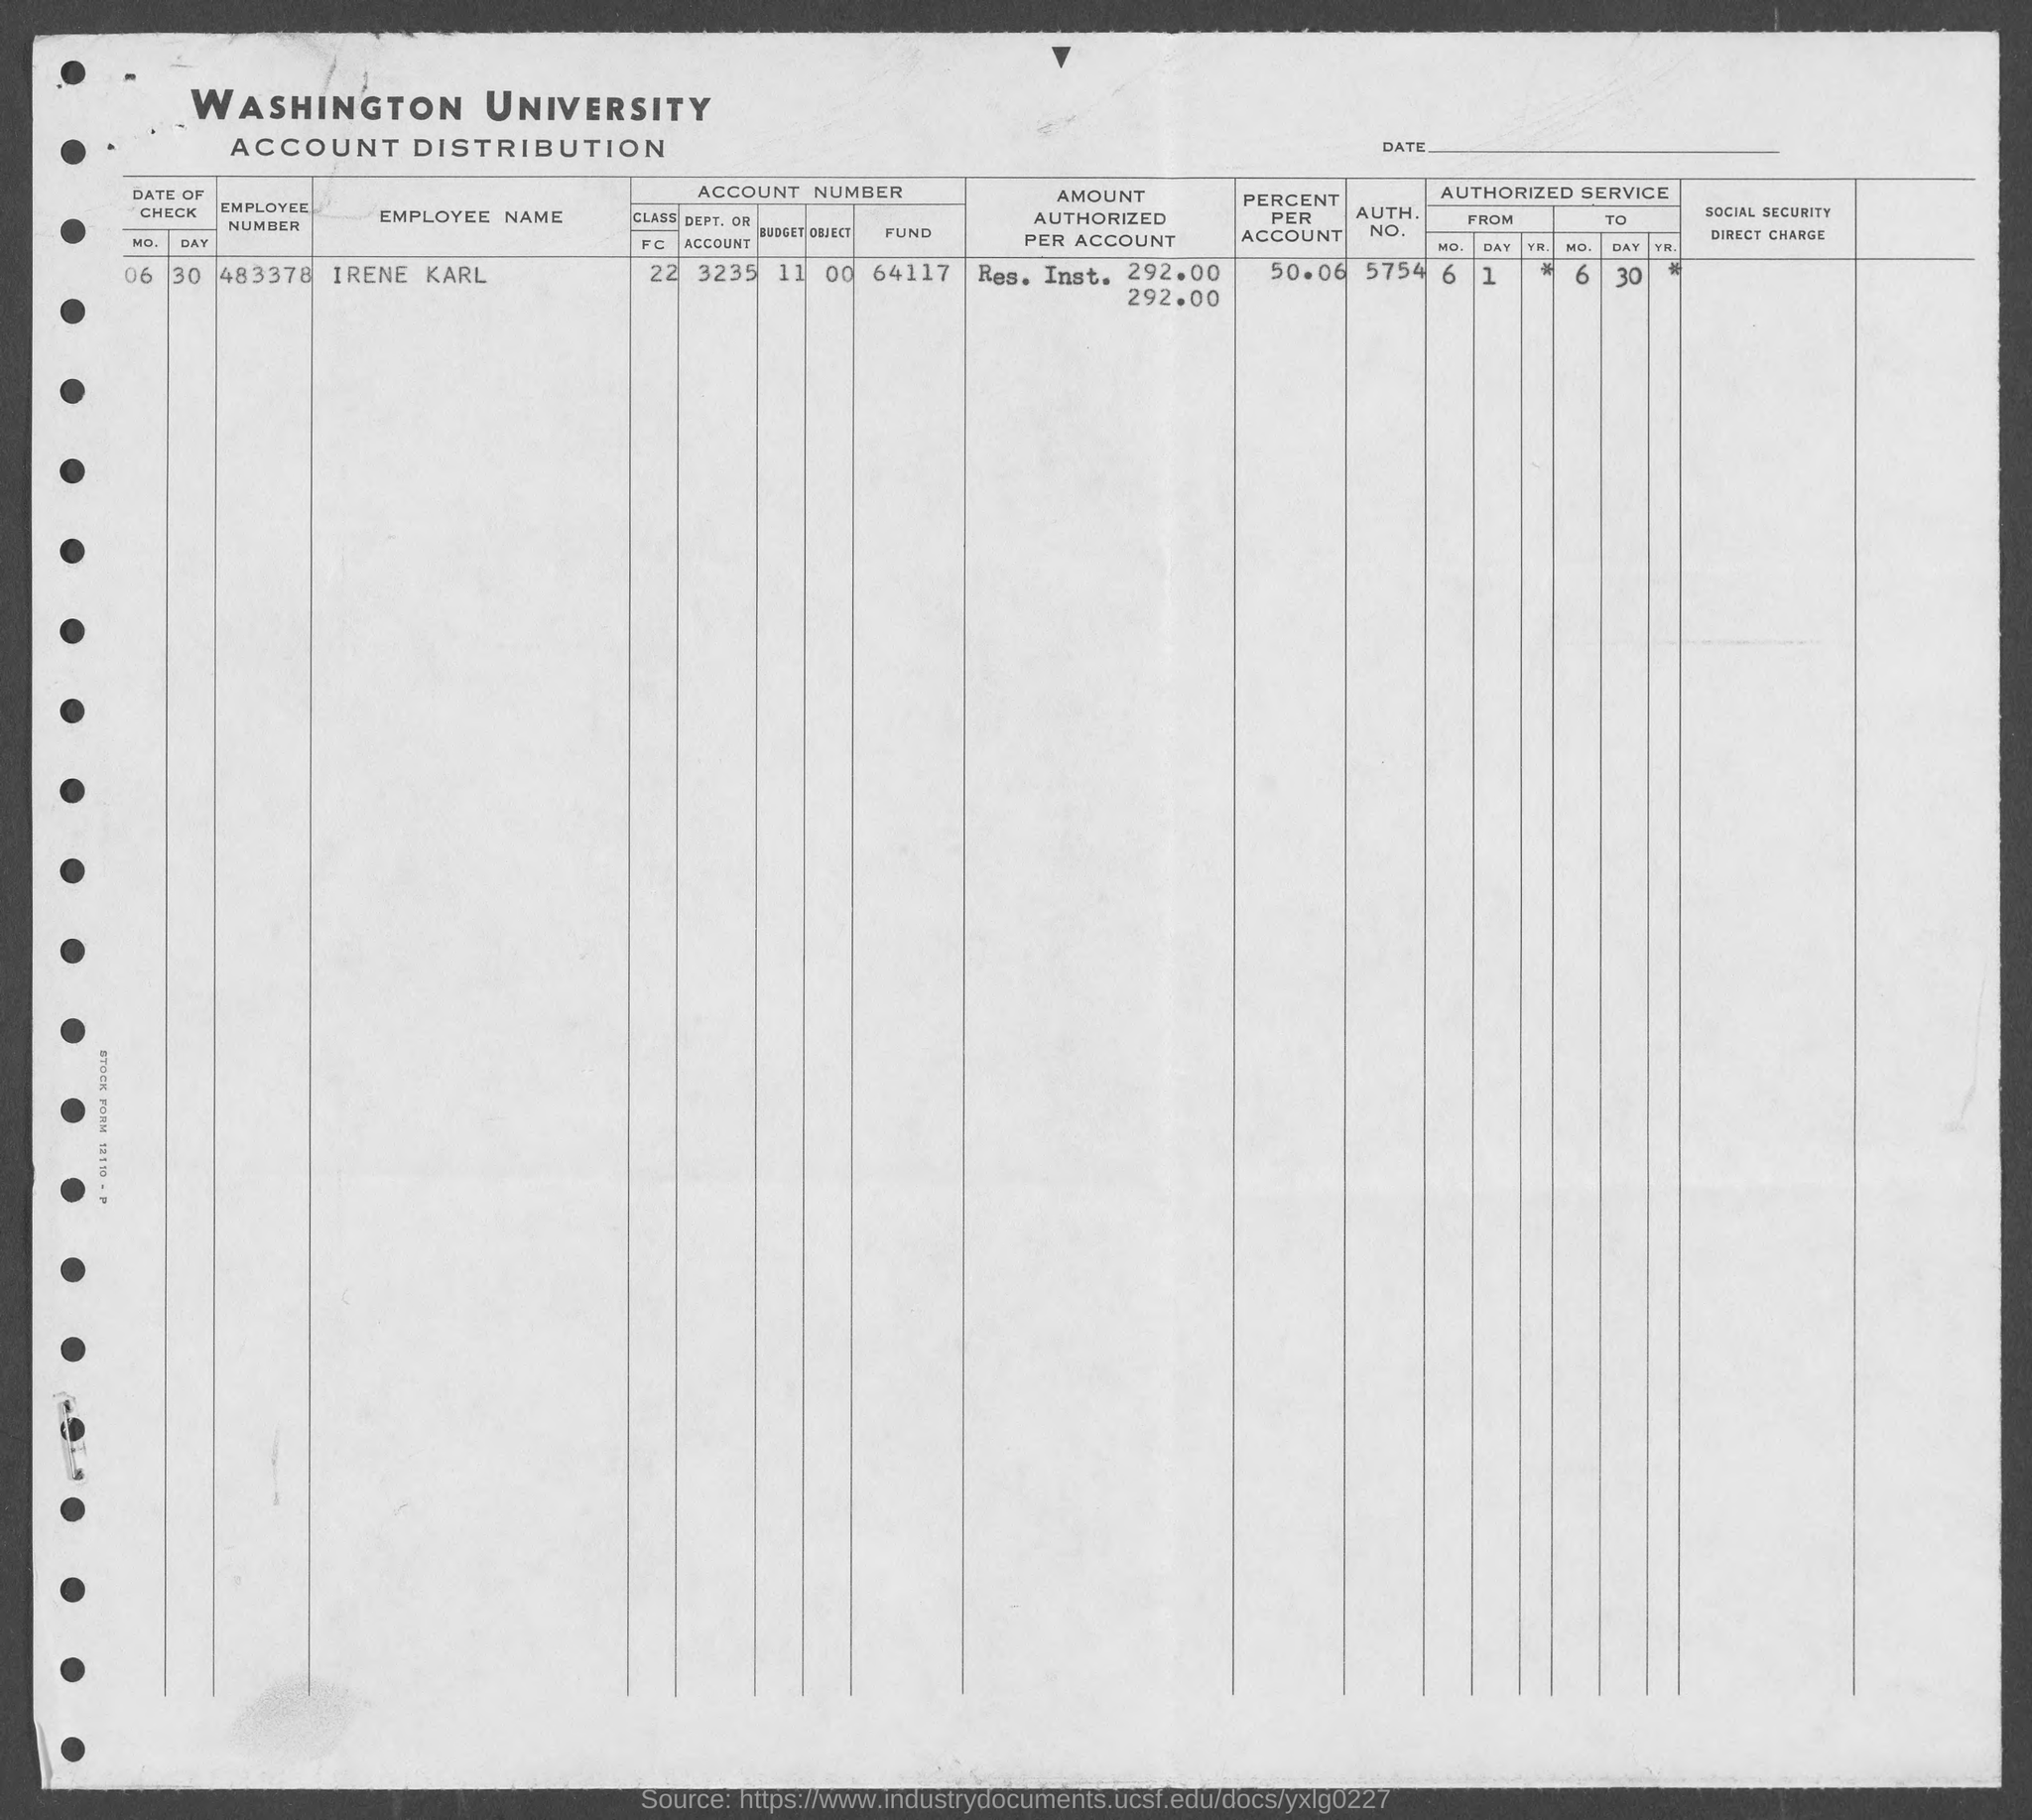What is the auth. no. mentioned in the given form ?
Make the answer very short. 5754. What is the value of percent per account as mentioned in the given form ?
Your answer should be compact. 50.06. What is the date of check mentioned in the given form ?
Your answer should be very brief. 06-30. What is the emp. no. mentioned in the given form ?
Keep it short and to the point. 483378. What is the employee name mentioned in the given form ?
Provide a short and direct response. Irene Karl. What is the account number mentioned in the given form ?
Ensure brevity in your answer.  22 3235 11 00 64117. What is the value of amount authorized per account ?
Ensure brevity in your answer.  292.00. 